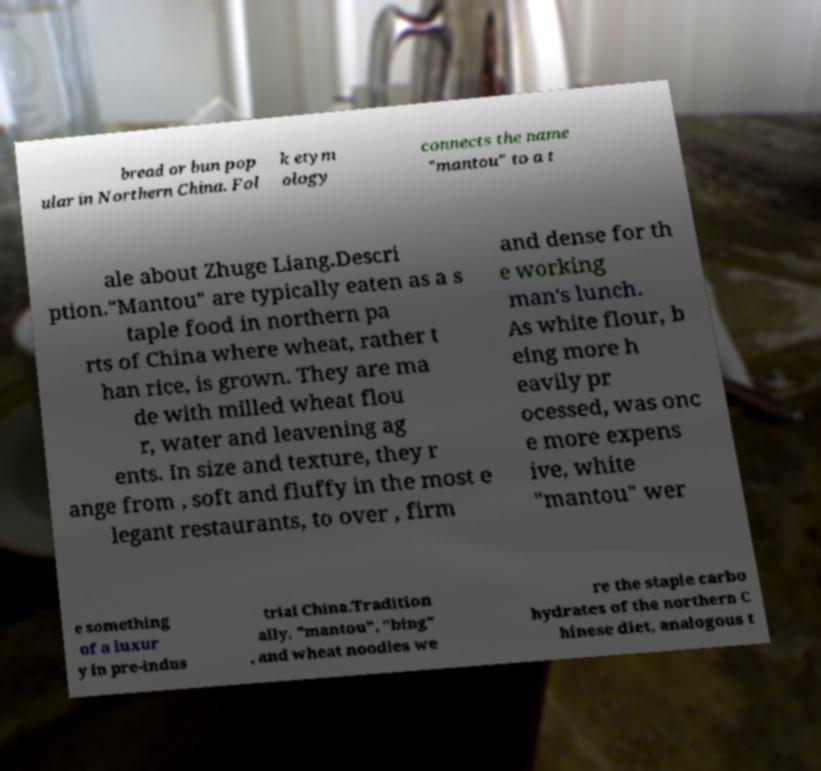Can you read and provide the text displayed in the image?This photo seems to have some interesting text. Can you extract and type it out for me? bread or bun pop ular in Northern China. Fol k etym ology connects the name "mantou" to a t ale about Zhuge Liang.Descri ption."Mantou" are typically eaten as a s taple food in northern pa rts of China where wheat, rather t han rice, is grown. They are ma de with milled wheat flou r, water and leavening ag ents. In size and texture, they r ange from , soft and fluffy in the most e legant restaurants, to over , firm and dense for th e working man's lunch. As white flour, b eing more h eavily pr ocessed, was onc e more expens ive, white "mantou" wer e something of a luxur y in pre-indus trial China.Tradition ally, "mantou", "bing" , and wheat noodles we re the staple carbo hydrates of the northern C hinese diet, analogous t 